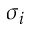<formula> <loc_0><loc_0><loc_500><loc_500>\sigma _ { i }</formula> 